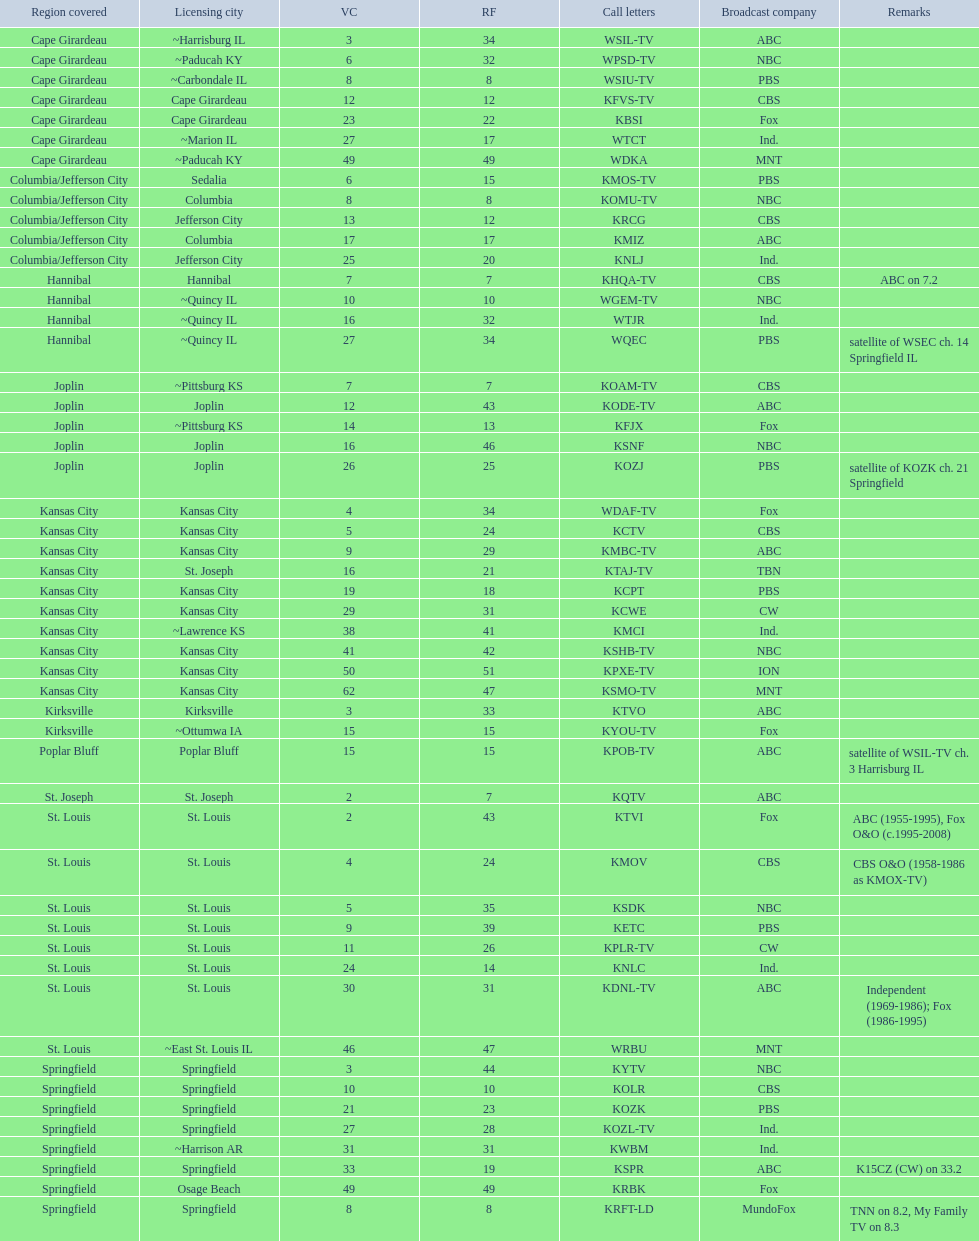How many are on the cbs network? 7. 